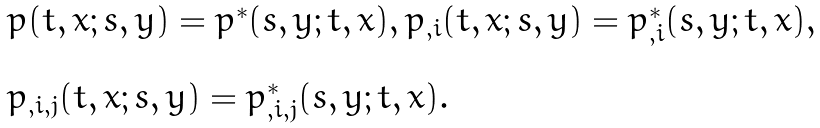<formula> <loc_0><loc_0><loc_500><loc_500>\begin{array} { l l } p ( t , x ; s , y ) = p ^ { * } ( s , y ; t , x ) , p _ { , i } ( t , x ; s , y ) = p ^ { * } _ { , i } ( s , y ; t , x ) , \\ \\ p _ { , i , j } ( t , x ; s , y ) = p ^ { * } _ { , i , j } ( s , y ; t , x ) . \end{array}</formula> 